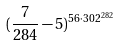Convert formula to latex. <formula><loc_0><loc_0><loc_500><loc_500>( \frac { 7 } { 2 8 4 } - 5 ) ^ { 5 6 \cdot 3 0 2 ^ { 2 8 2 } }</formula> 